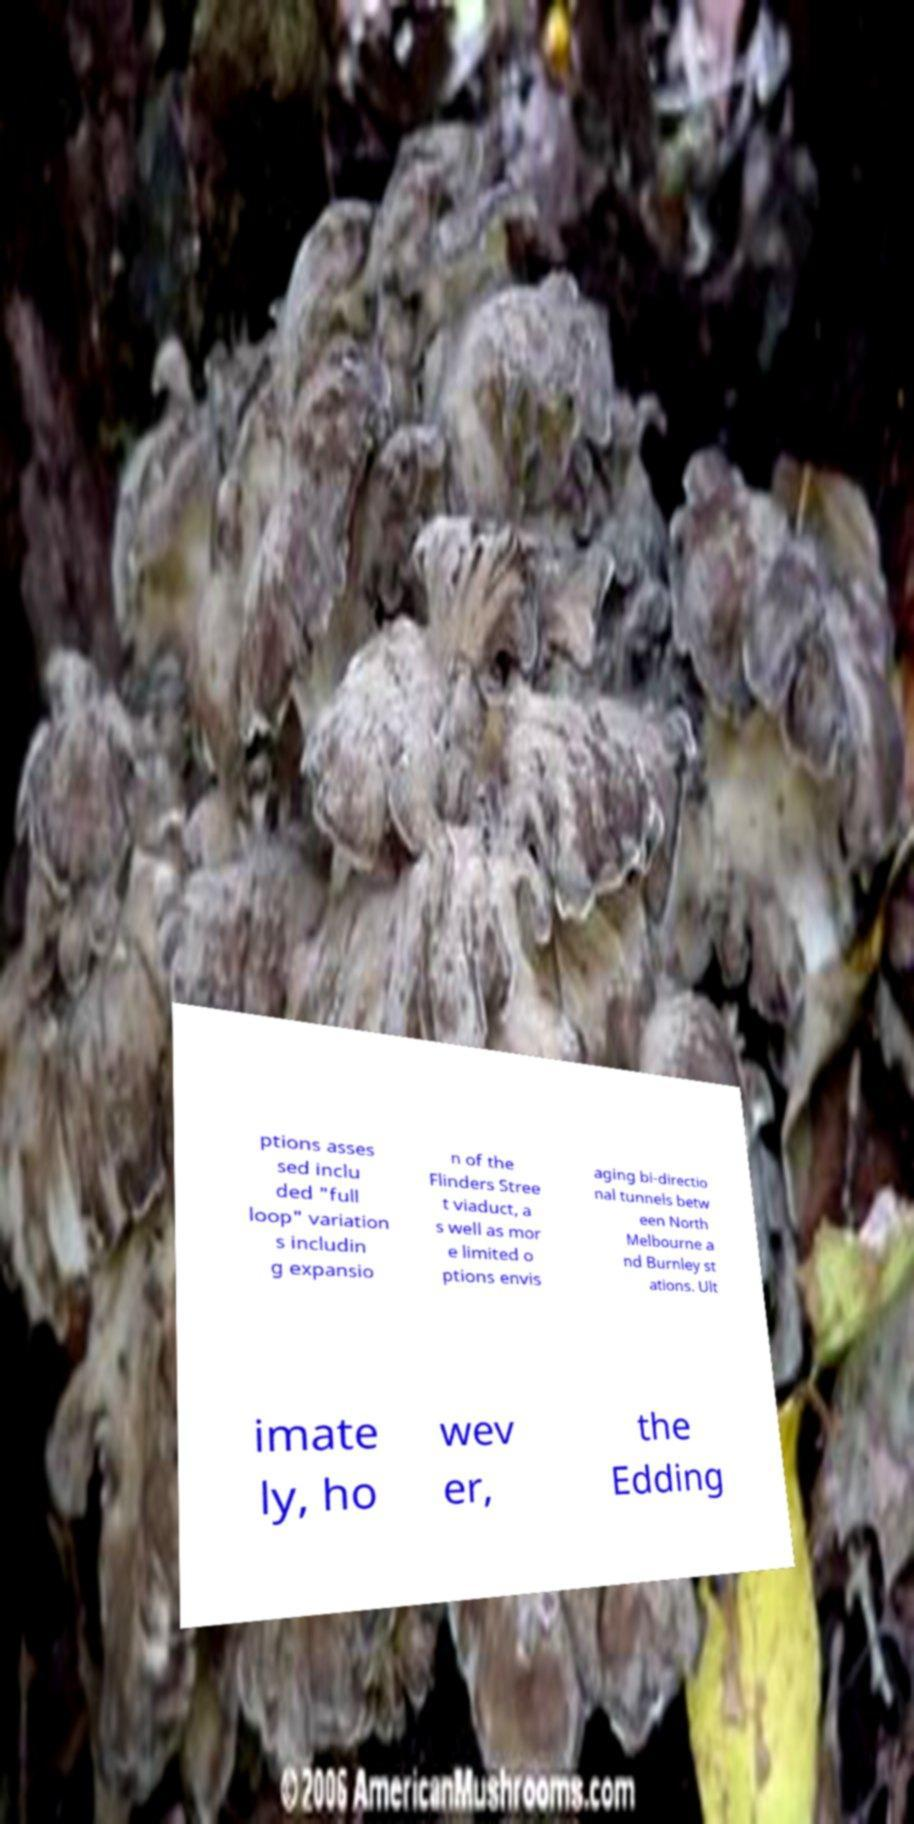For documentation purposes, I need the text within this image transcribed. Could you provide that? ptions asses sed inclu ded "full loop" variation s includin g expansio n of the Flinders Stree t viaduct, a s well as mor e limited o ptions envis aging bi-directio nal tunnels betw een North Melbourne a nd Burnley st ations. Ult imate ly, ho wev er, the Edding 